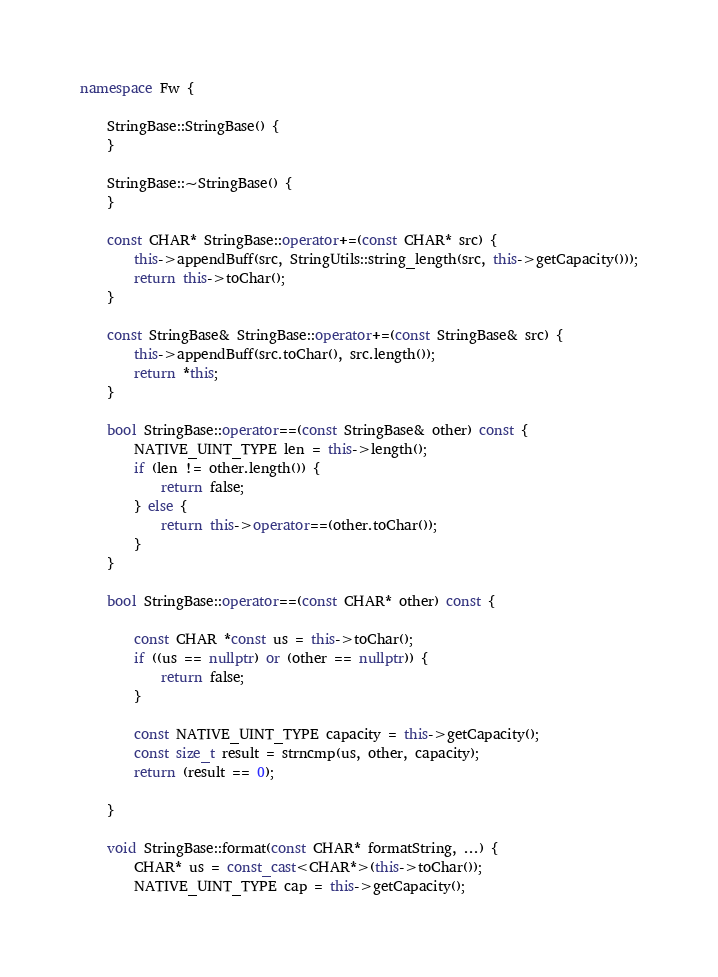Convert code to text. <code><loc_0><loc_0><loc_500><loc_500><_C++_>
namespace Fw {

    StringBase::StringBase() {
    }

    StringBase::~StringBase() {
    }

    const CHAR* StringBase::operator+=(const CHAR* src) {
        this->appendBuff(src, StringUtils::string_length(src, this->getCapacity()));
        return this->toChar();
    }

    const StringBase& StringBase::operator+=(const StringBase& src) {
        this->appendBuff(src.toChar(), src.length());
        return *this;
    }

    bool StringBase::operator==(const StringBase& other) const {
        NATIVE_UINT_TYPE len = this->length();
        if (len != other.length()) {
            return false;
        } else {
            return this->operator==(other.toChar());
        }
    }

    bool StringBase::operator==(const CHAR* other) const {

        const CHAR *const us = this->toChar();
        if ((us == nullptr) or (other == nullptr)) {
            return false;
        }

        const NATIVE_UINT_TYPE capacity = this->getCapacity();
        const size_t result = strncmp(us, other, capacity);
        return (result == 0);

    }

    void StringBase::format(const CHAR* formatString, ...) {
        CHAR* us = const_cast<CHAR*>(this->toChar());
        NATIVE_UINT_TYPE cap = this->getCapacity();</code> 